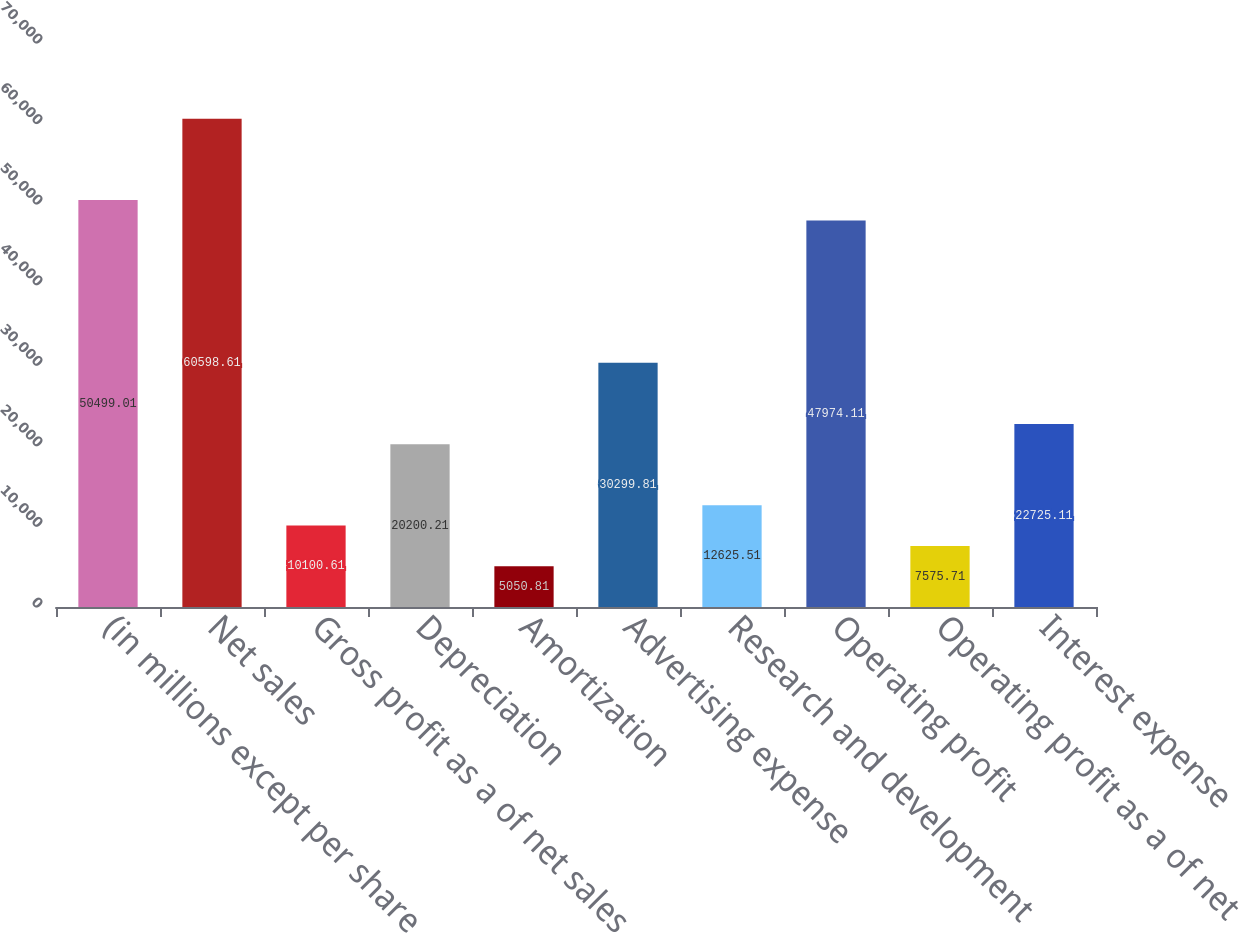Convert chart. <chart><loc_0><loc_0><loc_500><loc_500><bar_chart><fcel>(in millions except per share<fcel>Net sales<fcel>Gross profit as a of net sales<fcel>Depreciation<fcel>Amortization<fcel>Advertising expense<fcel>Research and development<fcel>Operating profit<fcel>Operating profit as a of net<fcel>Interest expense<nl><fcel>50499<fcel>60598.6<fcel>10100.6<fcel>20200.2<fcel>5050.81<fcel>30299.8<fcel>12625.5<fcel>47974.1<fcel>7575.71<fcel>22725.1<nl></chart> 